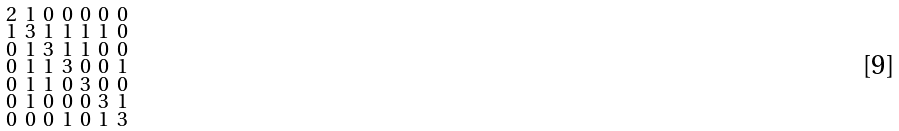Convert formula to latex. <formula><loc_0><loc_0><loc_500><loc_500>\begin{smallmatrix} 2 & 1 & 0 & 0 & 0 & 0 & 0 \\ 1 & 3 & 1 & 1 & 1 & 1 & 0 \\ 0 & 1 & 3 & 1 & 1 & 0 & 0 \\ 0 & 1 & 1 & 3 & 0 & 0 & 1 \\ 0 & 1 & 1 & 0 & 3 & 0 & 0 \\ 0 & 1 & 0 & 0 & 0 & 3 & 1 \\ 0 & 0 & 0 & 1 & 0 & 1 & 3 \end{smallmatrix}</formula> 